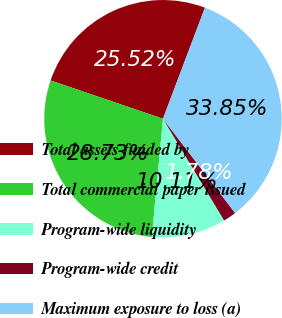Convert chart to OTSL. <chart><loc_0><loc_0><loc_500><loc_500><pie_chart><fcel>Total assets funded by<fcel>Total commercial paper issued<fcel>Program-wide liquidity<fcel>Program-wide credit<fcel>Maximum exposure to loss (a)<nl><fcel>25.52%<fcel>28.73%<fcel>10.11%<fcel>1.78%<fcel>33.85%<nl></chart> 